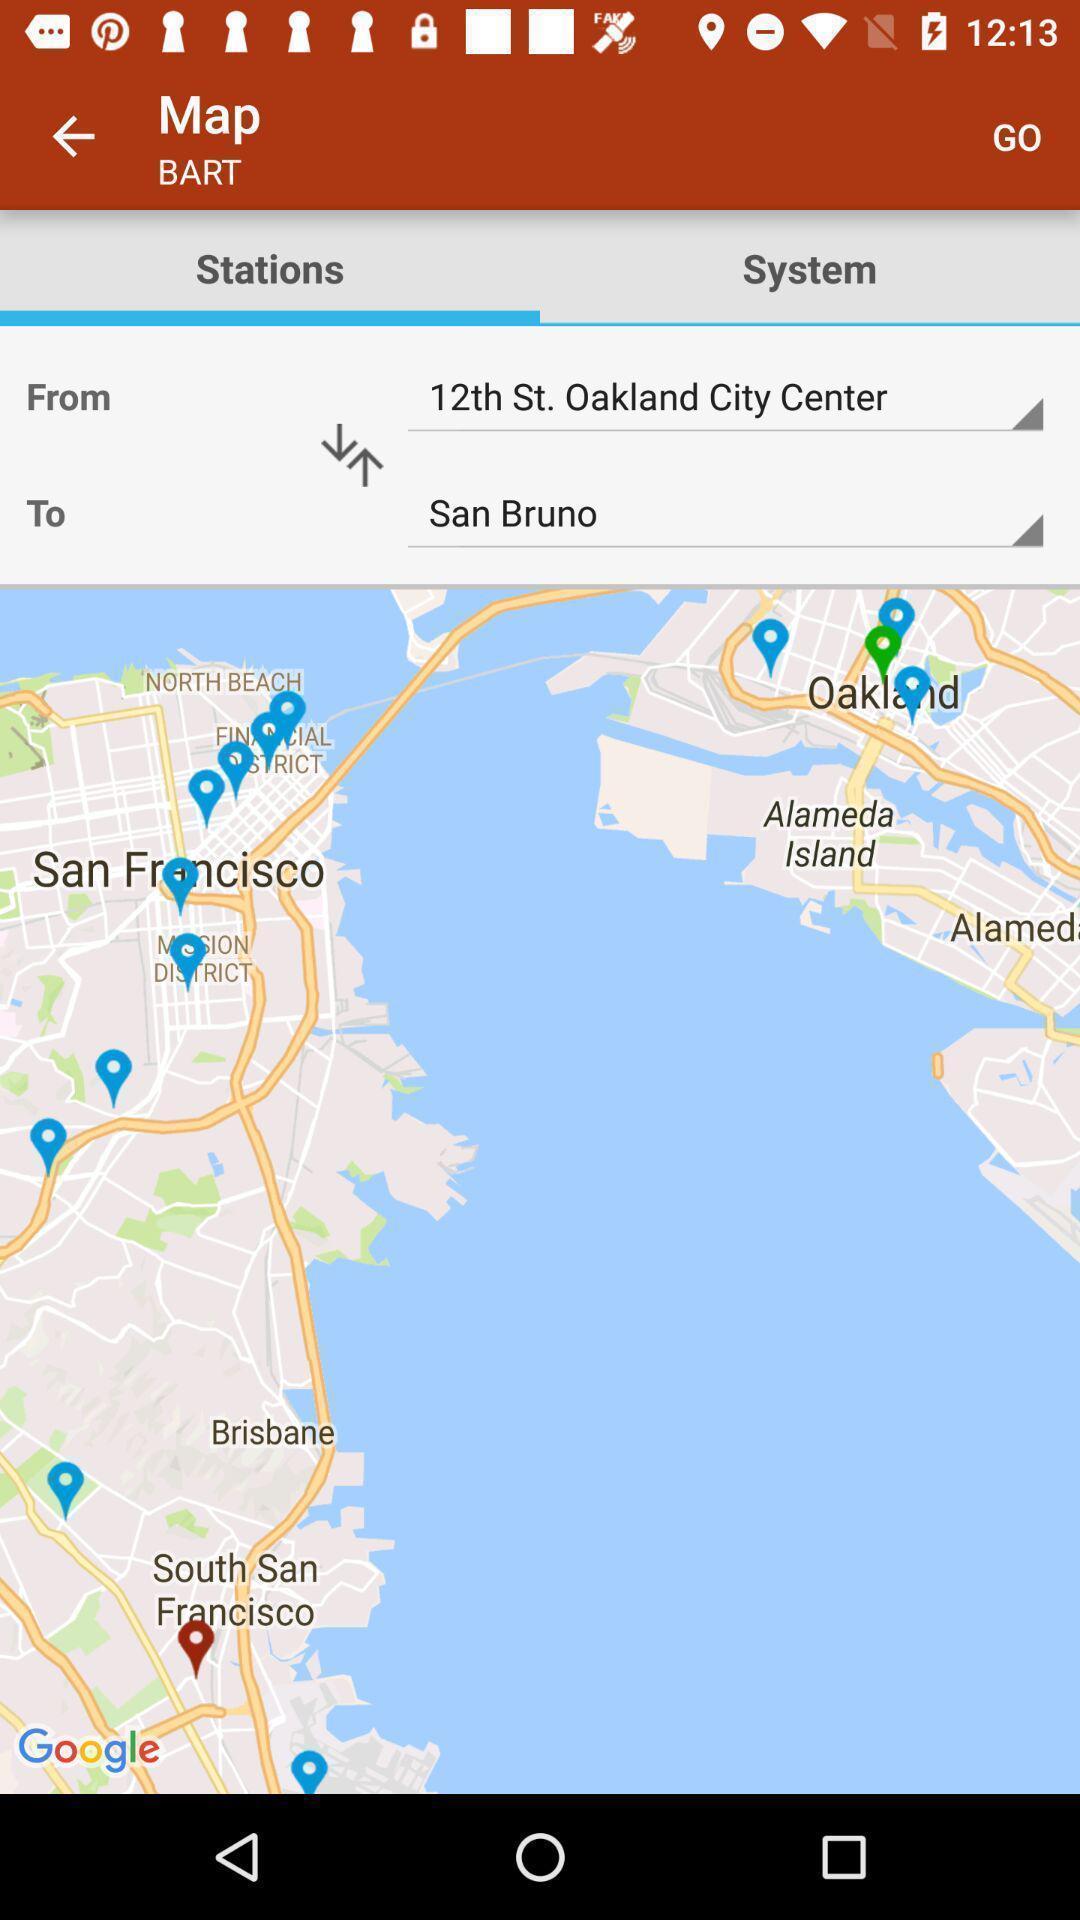Explain the elements present in this screenshot. Screen shows location of a map. 